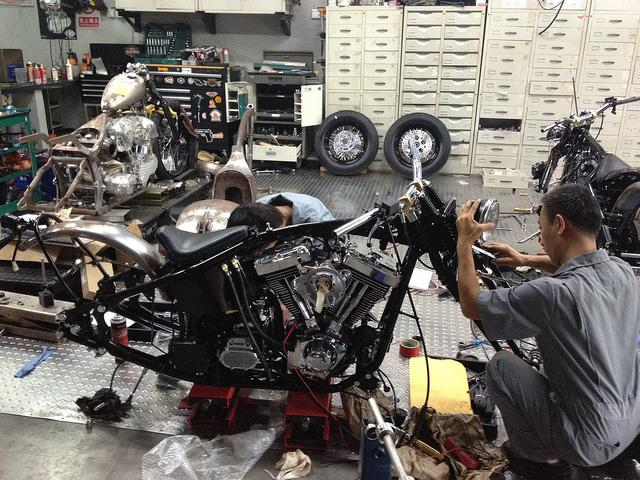What are the cabinets in the background called? file cabinet 